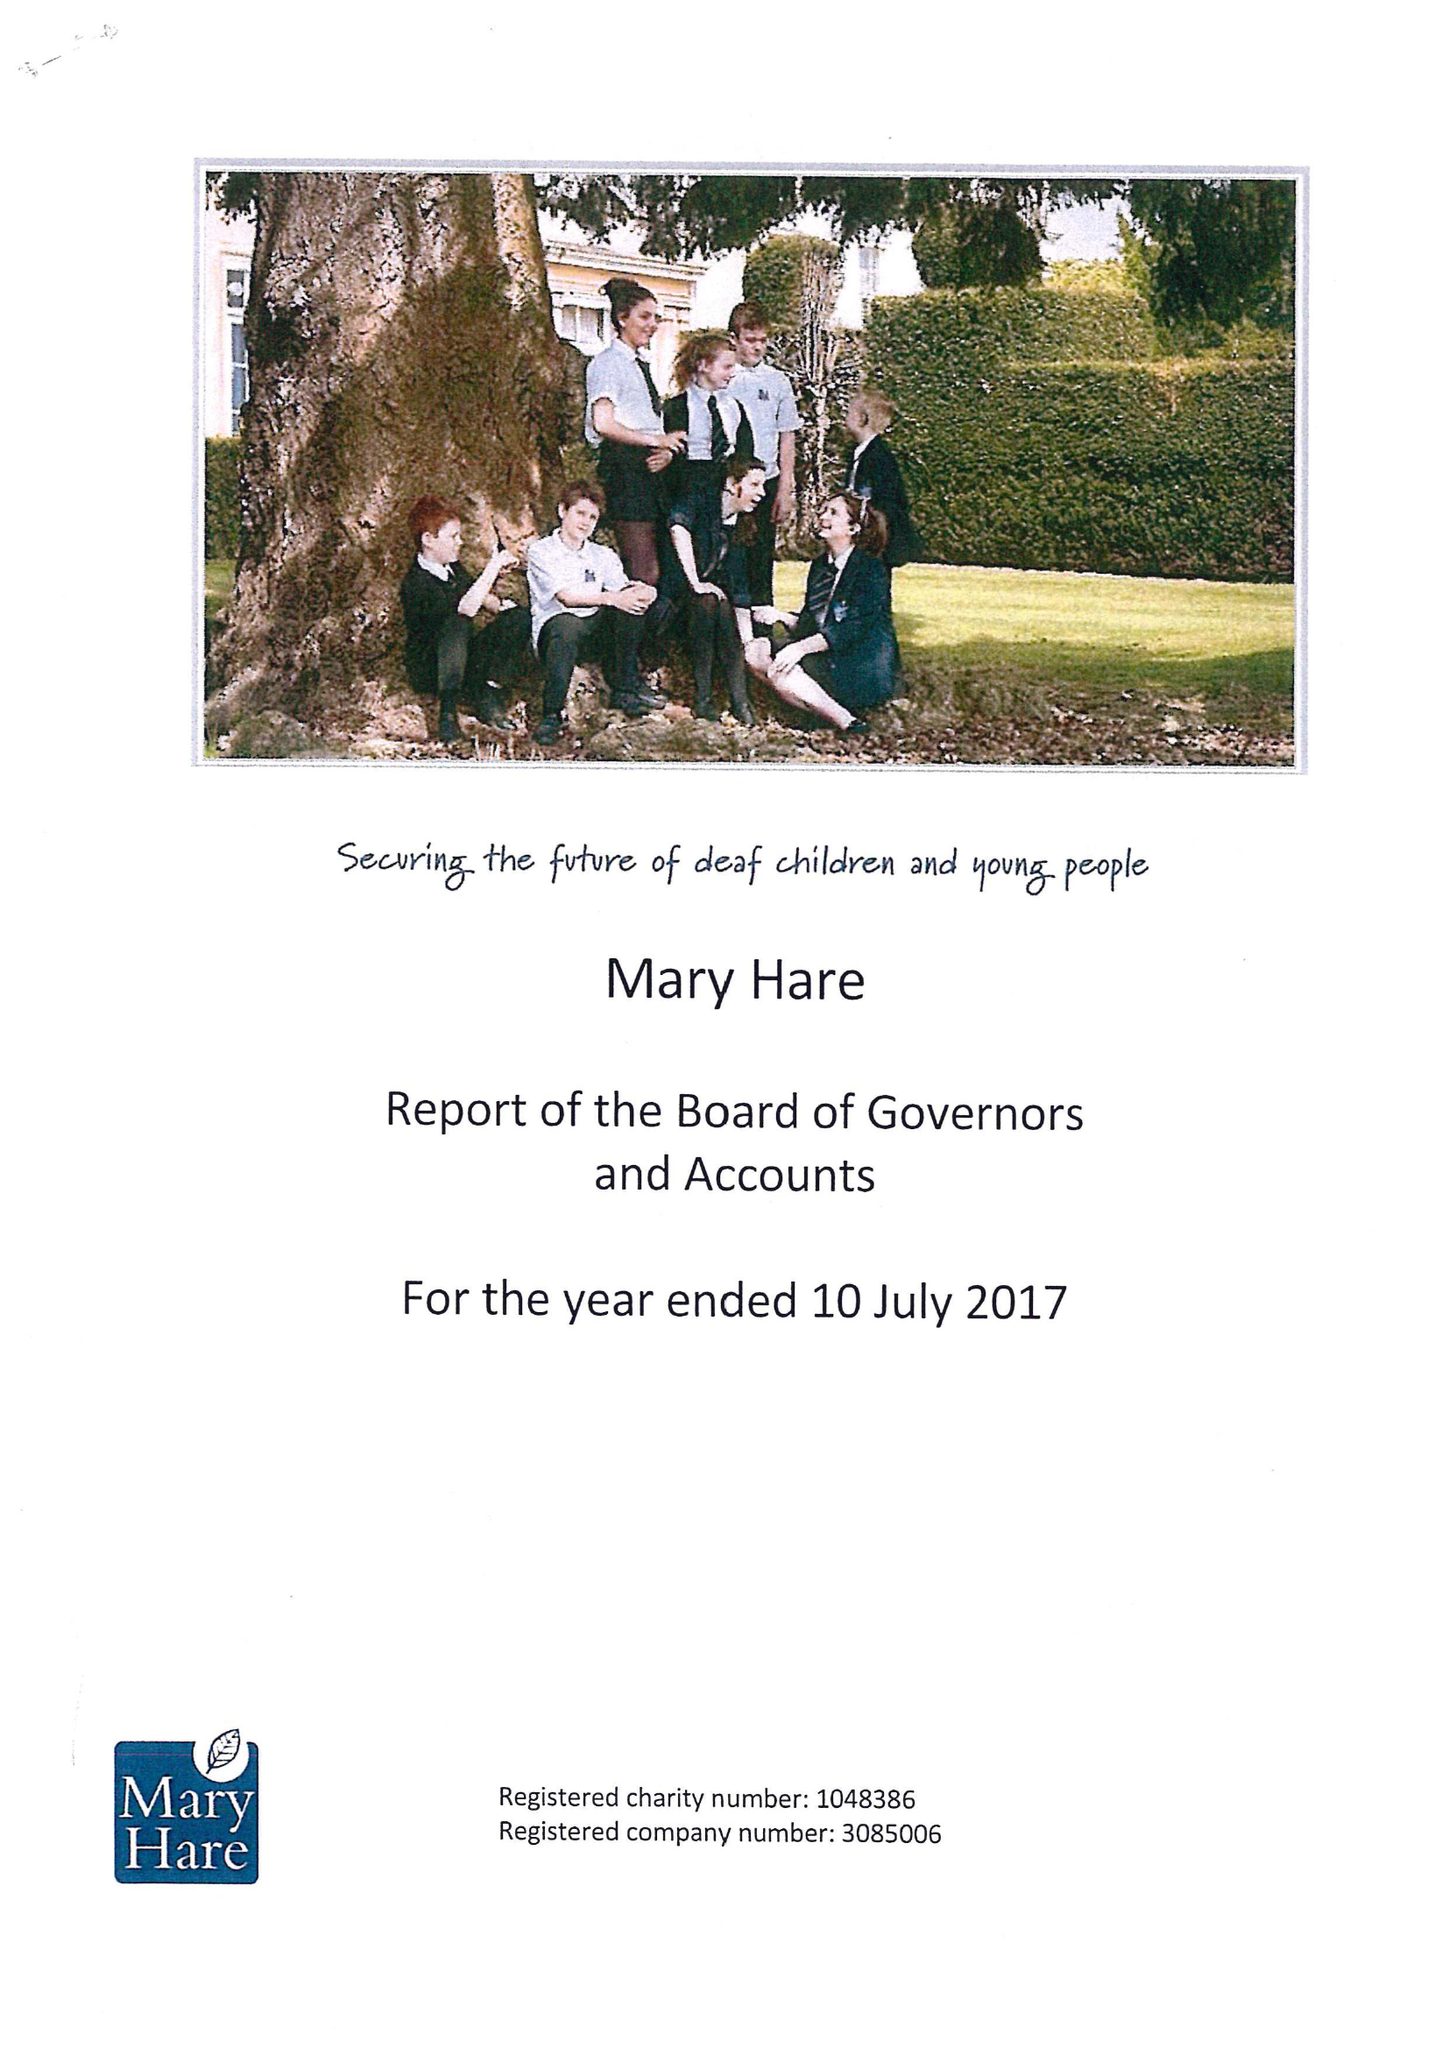What is the value for the address__post_town?
Answer the question using a single word or phrase. NEWBURY 